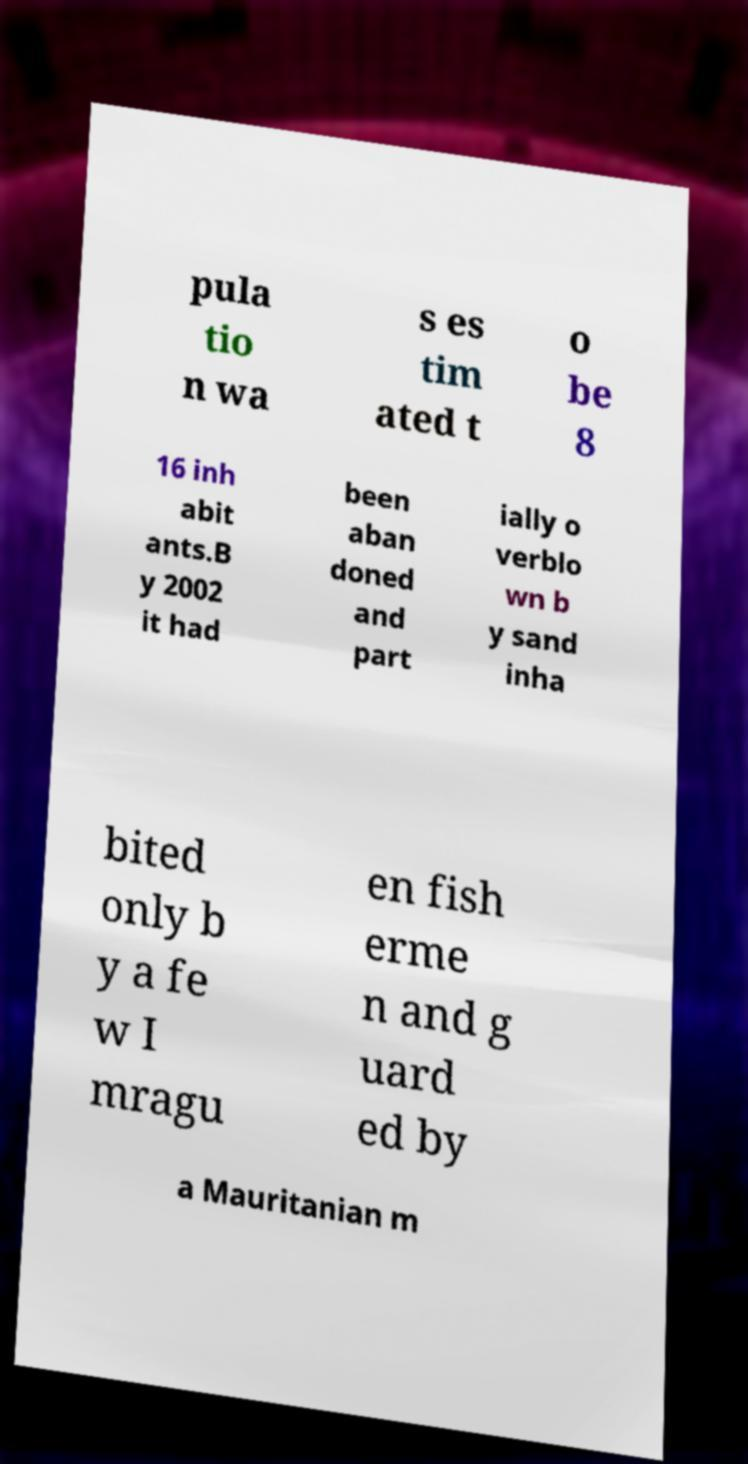I need the written content from this picture converted into text. Can you do that? pula tio n wa s es tim ated t o be 8 16 inh abit ants.B y 2002 it had been aban doned and part ially o verblo wn b y sand inha bited only b y a fe w I mragu en fish erme n and g uard ed by a Mauritanian m 